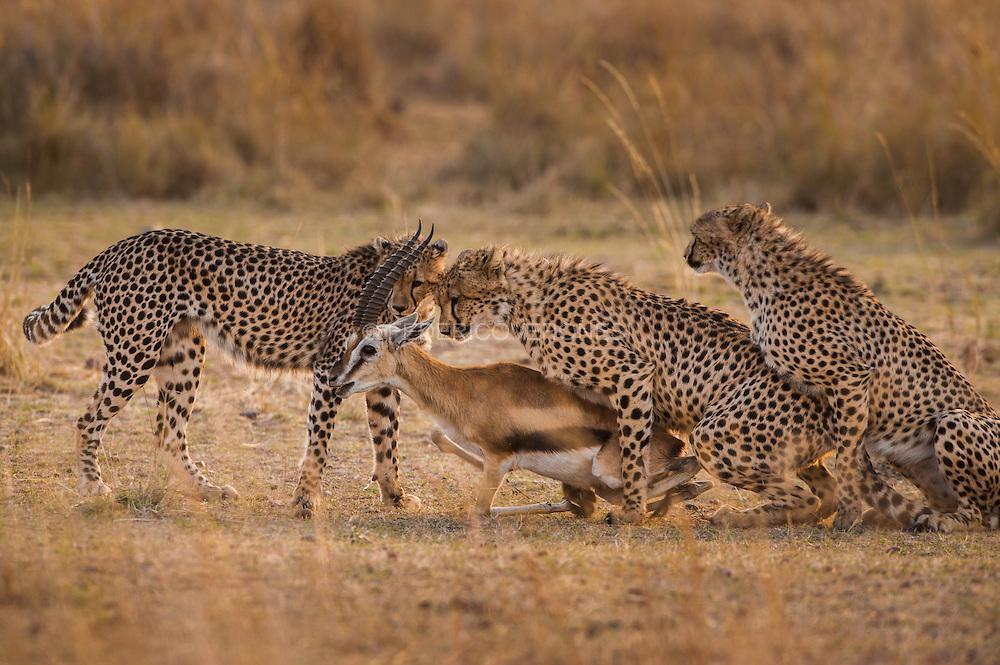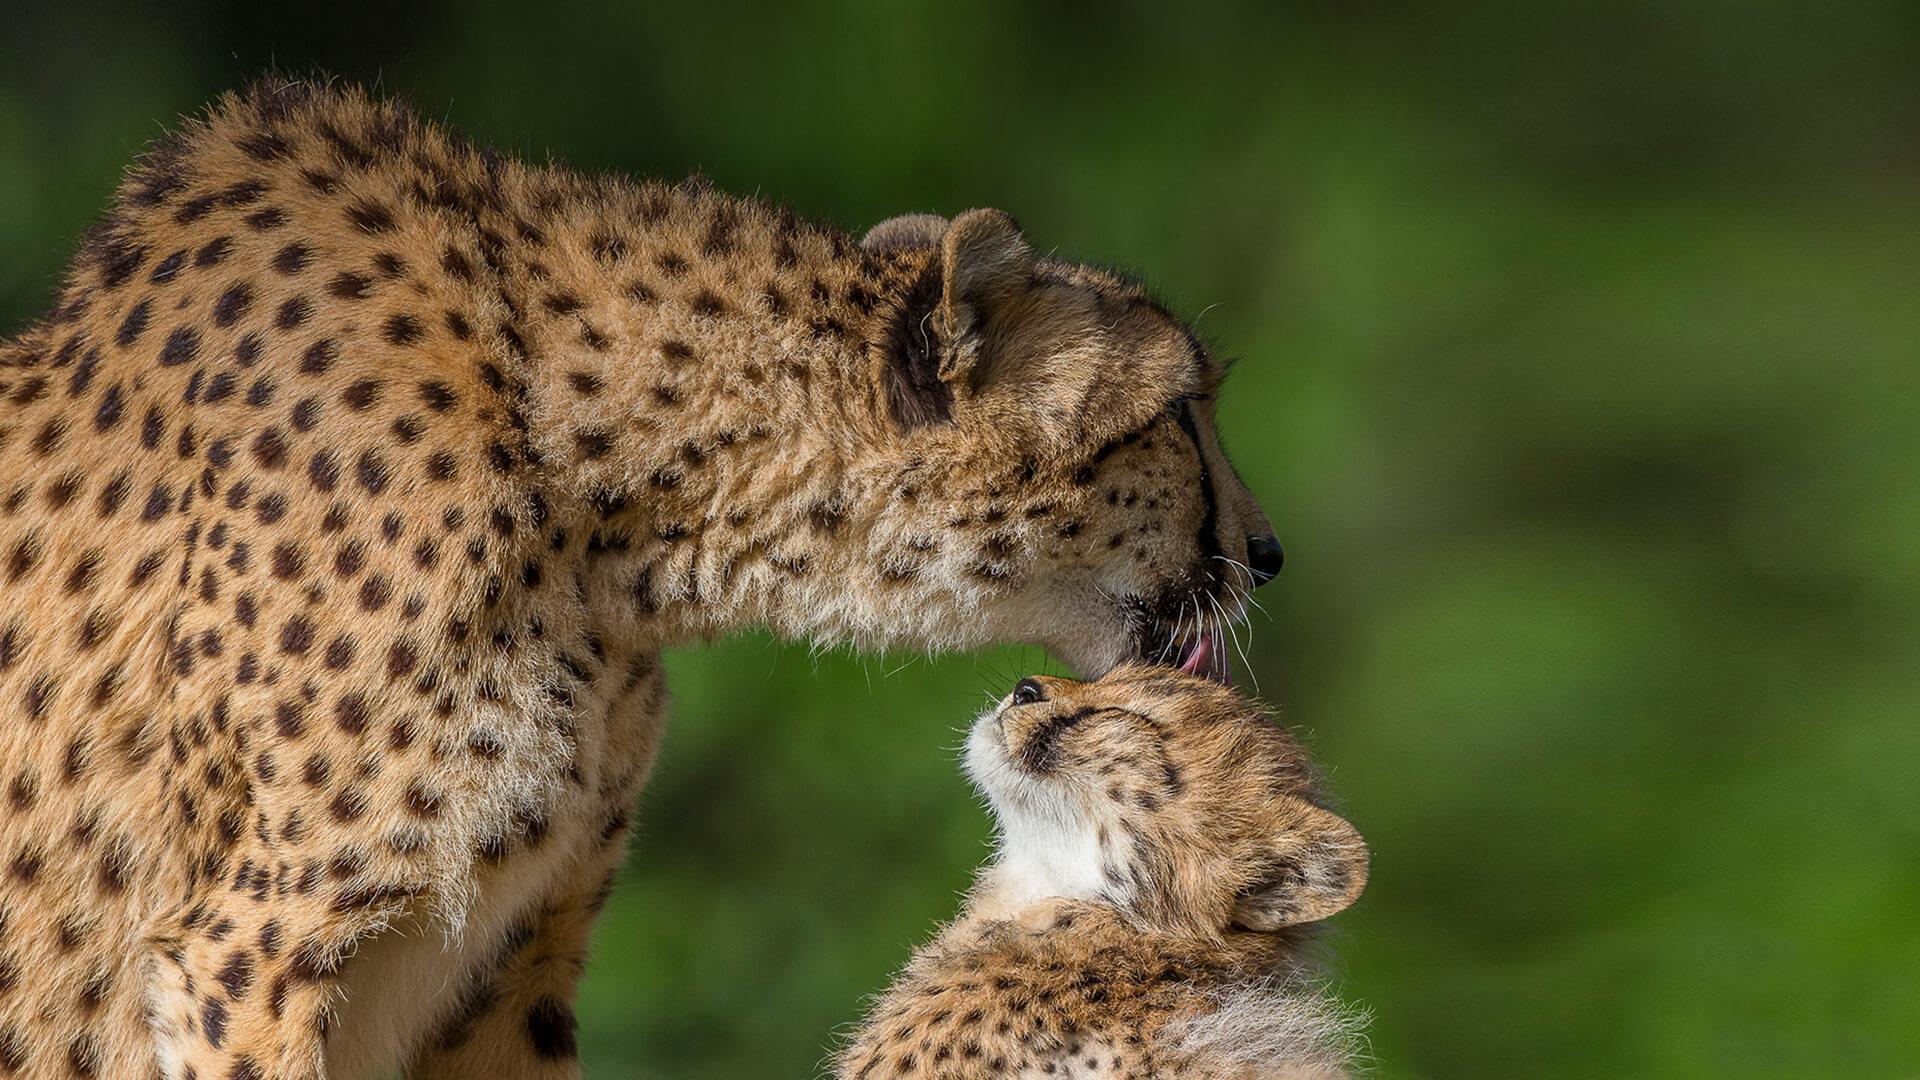The first image is the image on the left, the second image is the image on the right. Considering the images on both sides, is "The right image contains two or less baby cheetahs." valid? Answer yes or no. Yes. The first image is the image on the left, the second image is the image on the right. For the images displayed, is the sentence "Left image shows a close group of at least four cheetahs." factually correct? Answer yes or no. No. 